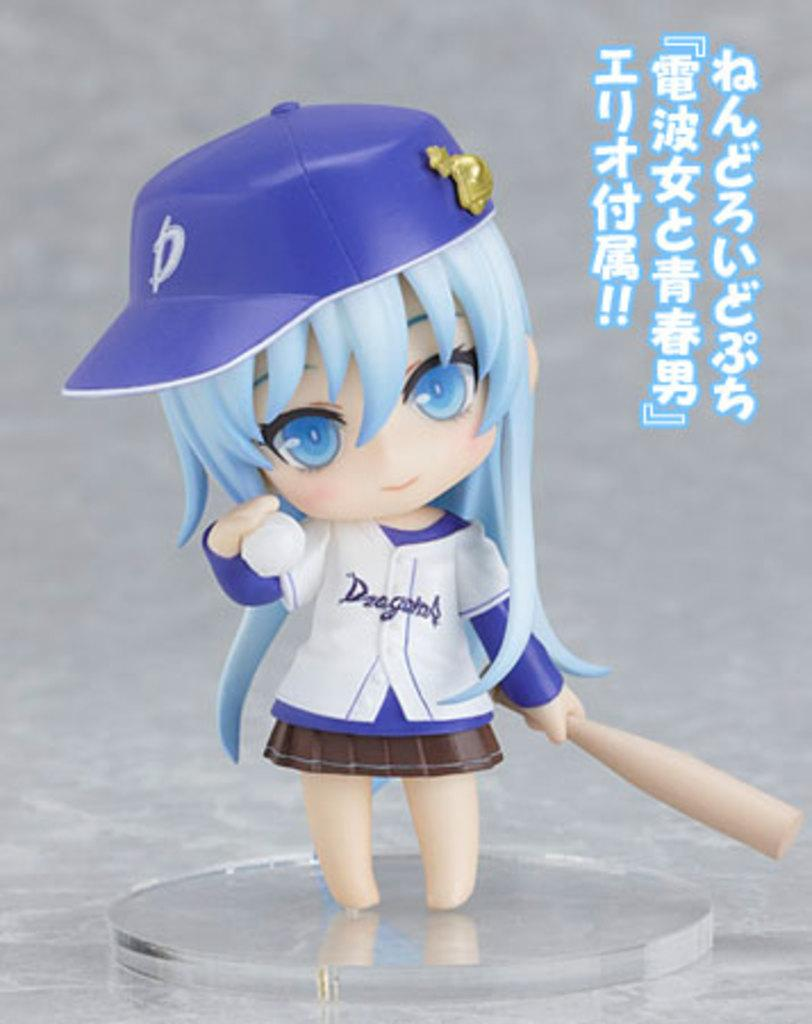What is the main subject of the image? There is a doll in the image. What is the doll placed on? The doll is on a glass object. What can be seen in the background of the image? There is a wall visible in the background of the image. Is there any additional information about the image itself? Yes, there is a watermark on the image. What type of sticks are being used for dinner in the image? There are no sticks or dinner present in the image; it features a doll on a glass object with a wall in the background. Can you see any ants crawling on the doll in the image? There are no ants visible in the image; it only features a doll on a glass object with a wall in the background. 